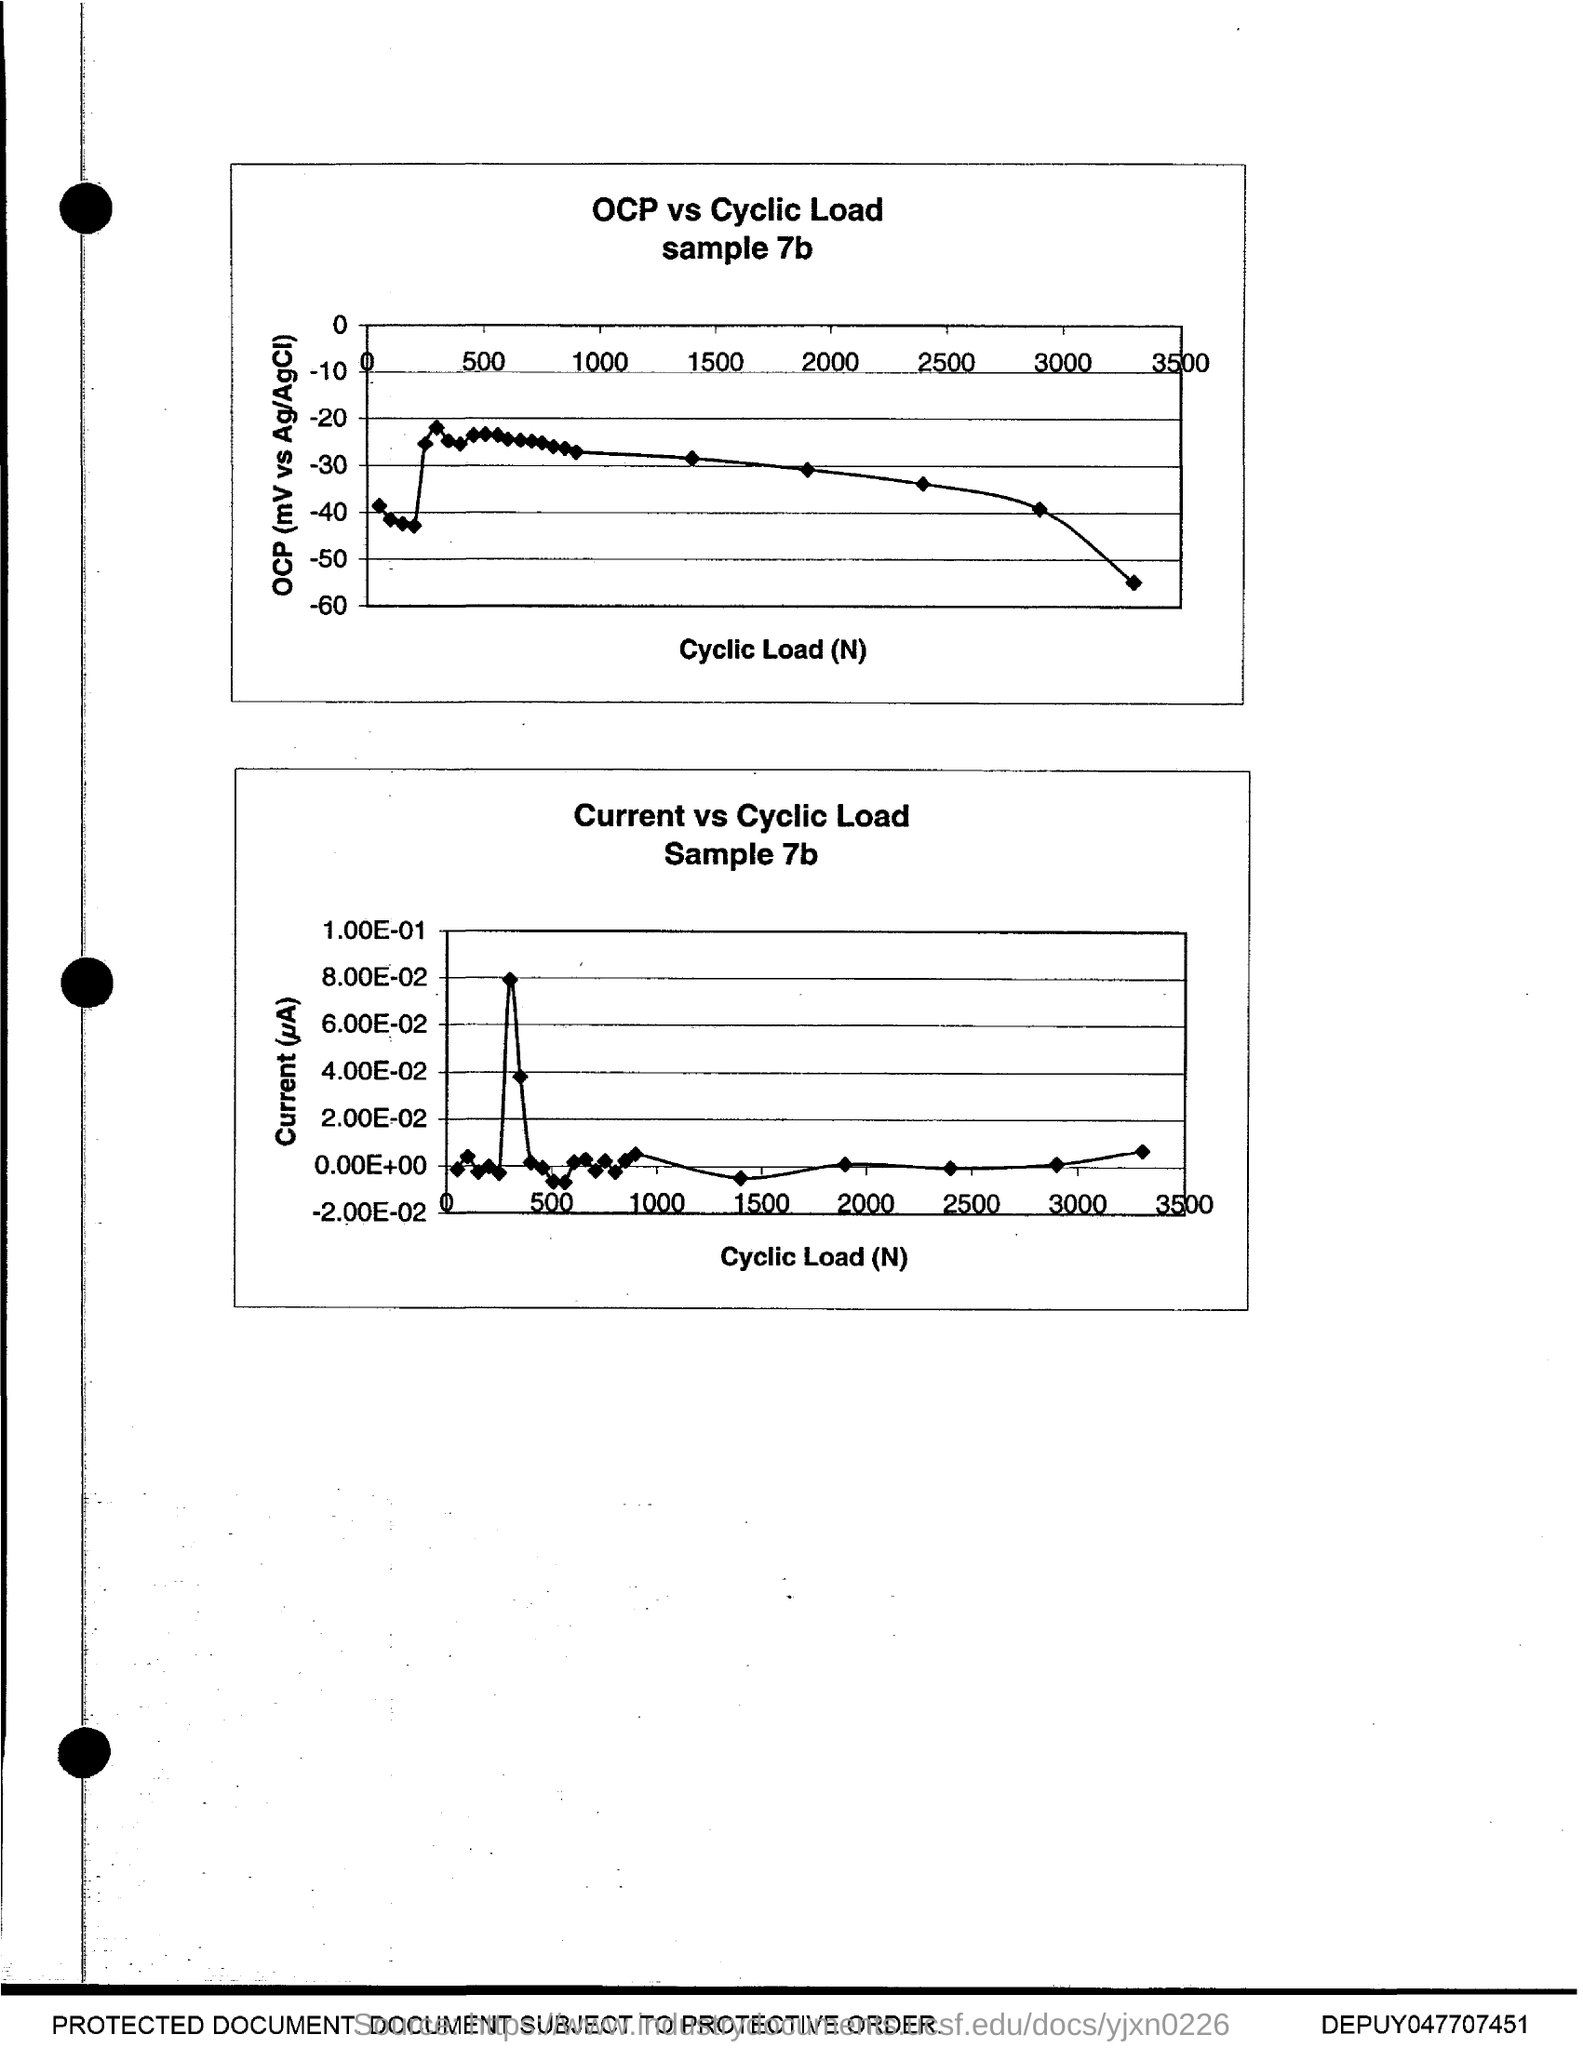What is plotted in the x-axis of both graph?
Your answer should be compact. Cyclic load (n). 